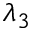Convert formula to latex. <formula><loc_0><loc_0><loc_500><loc_500>\lambda _ { 3 }</formula> 